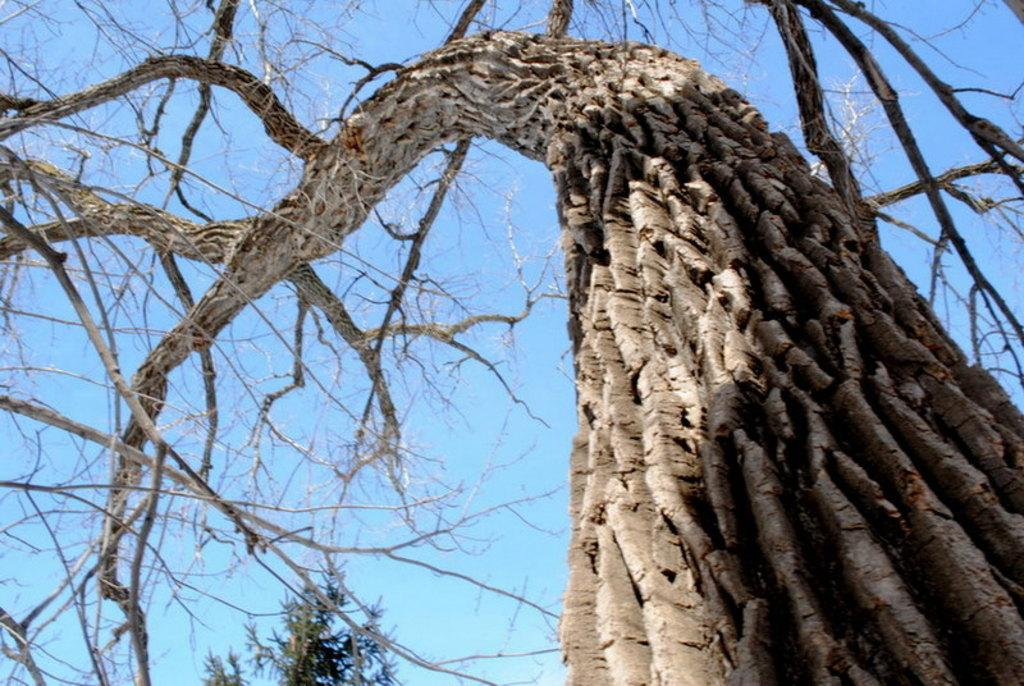What type of tree is in the foreground of the image? There is a dry tree in the foreground of the image. Can you describe the tree in the background of the image? There is a tree visible in the background of the image. What can be seen in the sky in the image? The sky is visible in the image. How many cats are sitting on the dry tree in the image? There are no cats present in the image, so it is not possible to determine how many might be sitting on the dry tree. 